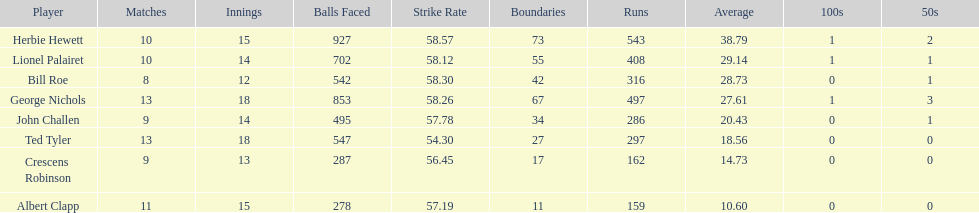Which player had the least amount of runs? Albert Clapp. 